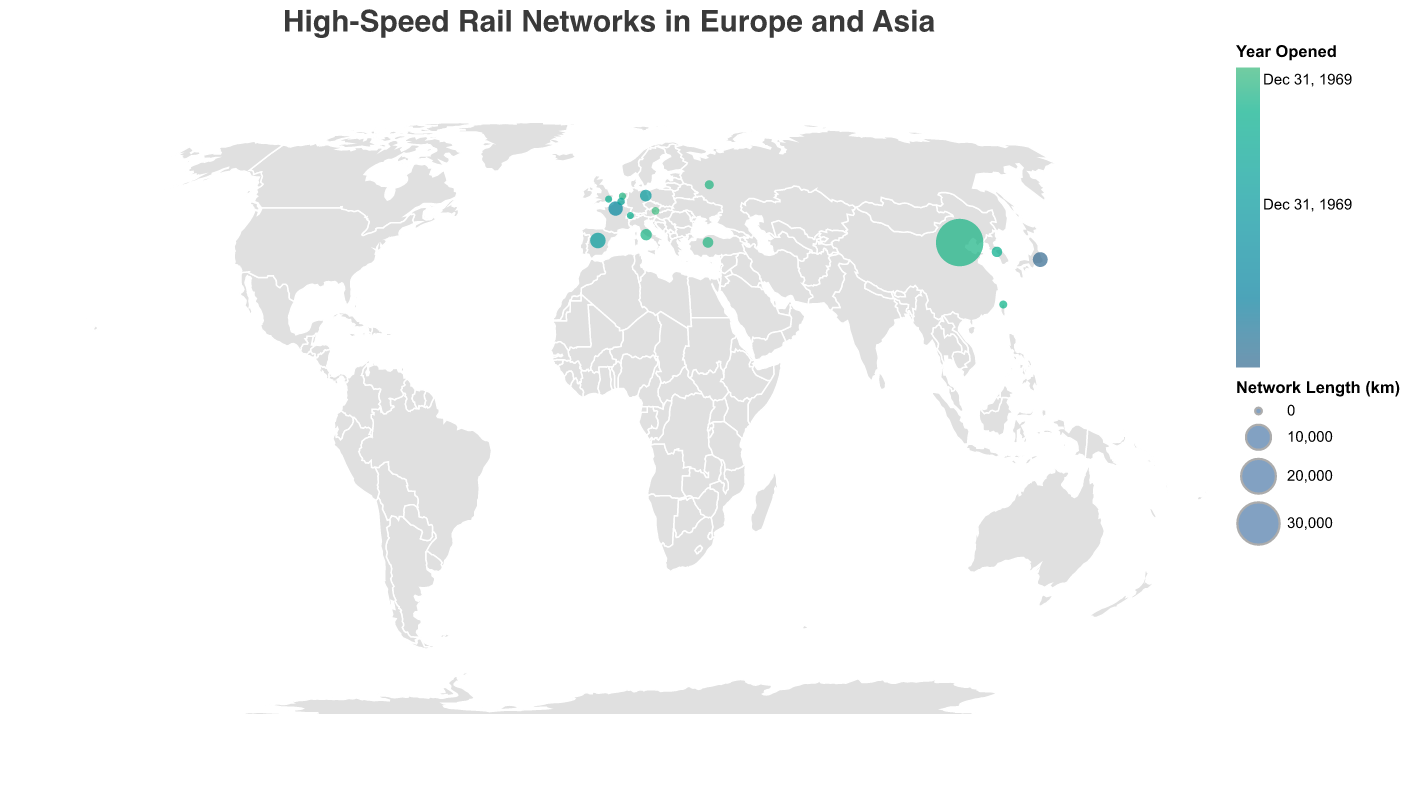Which country has the longest high-speed rail network? By looking at the size of the circles, China has the largest circle, indicating the longest rail network. The tooltip confirms that China has a network length of 38000 km.
Answer: China Which city opened its high-speed rail network first? The color scheme indicates that darker colors represent earlier years. Tokyo's Shinkansen network, shown in the darkest color, was opened in 1964.
Answer: Tokyo What is the total length of the high-speed rail networks in Europe? Sum the lengths of the networks in Europe: France (2800 km), Spain (3400 km), Germany (1571 km), Italy (1467 km), Turkey (1213 km), the United Kingdom (108 km), Netherlands (125 km), Belgium (209 km), Switzerland (92 km), Austria (254 km), and Russia (650 km). The total is 12889 km.
Answer: 12889 km Which Asian city has the second shortest high-speed rail network? In Asia, Taiwan's Taipei has the shortest network (350 km). The second shortest is South Korea’s Seoul with 1118 km.
Answer: Seoul Which European city opened its high-speed rail network most recently? The color lightest color represents the most recent opening. Vienna's ÖBB, represented in the lightest color, opened in 2012.
Answer: Vienna How does the network length of Japan's Shinkansen compare to Spain's AVE network? Japan's Shinkansen has a network length of 3041 km, while Spain's AVE has 3400 km. 3400 km is greater than 3041 km.
Answer: Spain's AVE is longer Which continent has more high-speed rail networks represented in the plot? Count the number of network points in each continent. Europe has more countries (France, Spain, Germany, Italy, Turkey, United Kingdom, Netherlands, Belgium, Switzerland, Austria, Russia) than Asia, which has fewer (China, Japan, South Korea, Taiwan).
Answer: Europe What is the average length of the high-speed rail networks in the given data? Sum all the lengths: 2800 + 3400 + 1571 + 1467 + 38000 + 3041 + 1118 + 350 + 1213 + 108 + 125 + 209 + 92 + 254 + 650 = 49898. Divide this by the number of networks, which is 15. 49898 / 15 = 3326.53 km.
Answer: 3326.53 km Which city in Europe has the shortest high-speed rail network? In Europe, Switzerland's Bern has the shortest rail network with 92 km, as indicated by the smallest circle.
Answer: Bern Which high-speed rail network was opened in the same year as Turkey's YHT? The tooltip shows that Turkey's YHT opened in 2009. Other networks checked for 2009 include the Netherlands (HSL-Zuid), and Russia (Sapsan). Only Russia's Sapsan was also opened in 2009.
Answer: Russia 